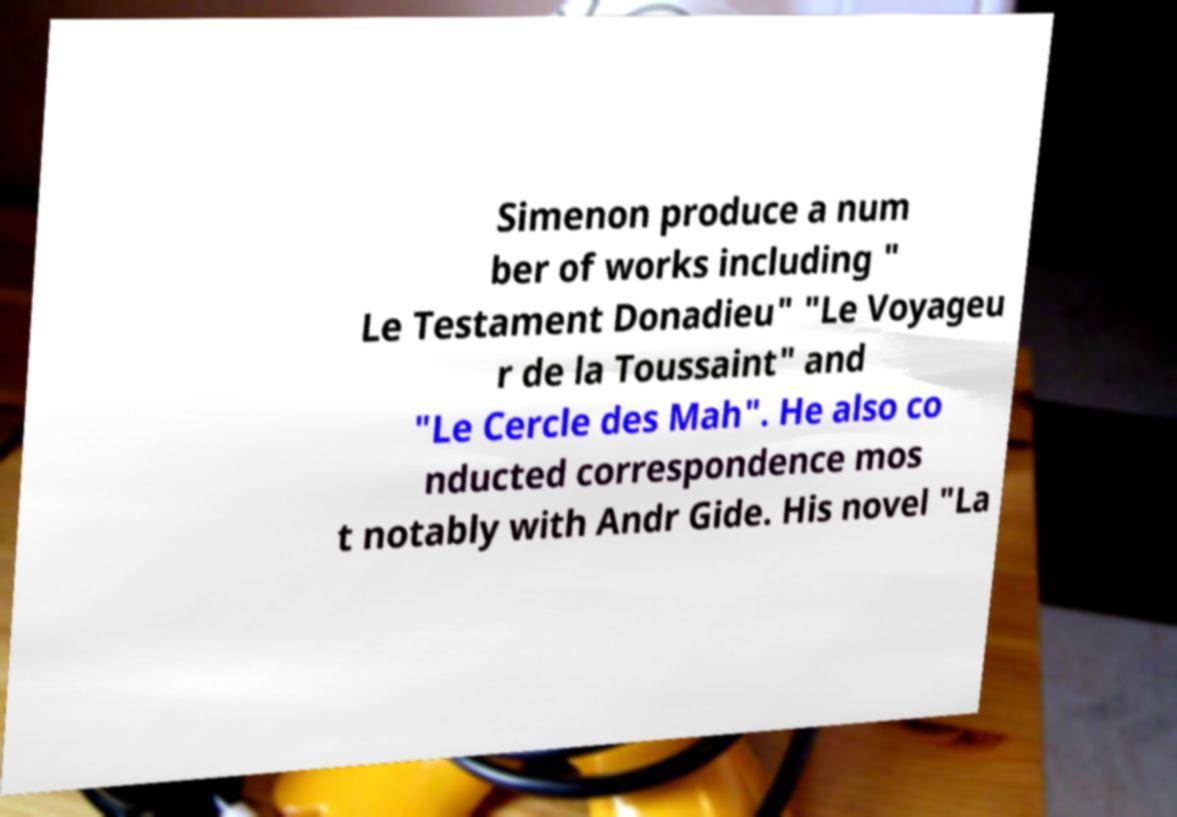Can you accurately transcribe the text from the provided image for me? Simenon produce a num ber of works including " Le Testament Donadieu" "Le Voyageu r de la Toussaint" and "Le Cercle des Mah". He also co nducted correspondence mos t notably with Andr Gide. His novel "La 